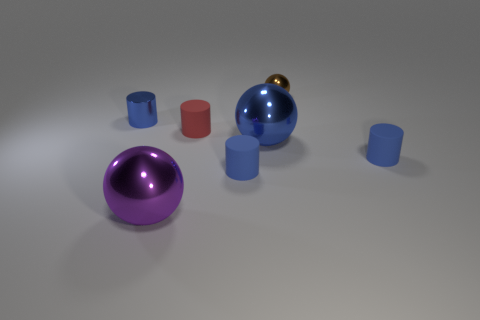Add 3 metallic things. How many objects exist? 10 Subtract all tiny blue cylinders. How many cylinders are left? 1 Subtract all blue spheres. How many spheres are left? 2 Subtract 1 cylinders. How many cylinders are left? 3 Subtract all gray spheres. How many blue cylinders are left? 3 Subtract all yellow matte spheres. Subtract all small things. How many objects are left? 2 Add 4 tiny brown spheres. How many tiny brown spheres are left? 5 Add 1 matte cylinders. How many matte cylinders exist? 4 Subtract 1 red cylinders. How many objects are left? 6 Subtract all cylinders. How many objects are left? 3 